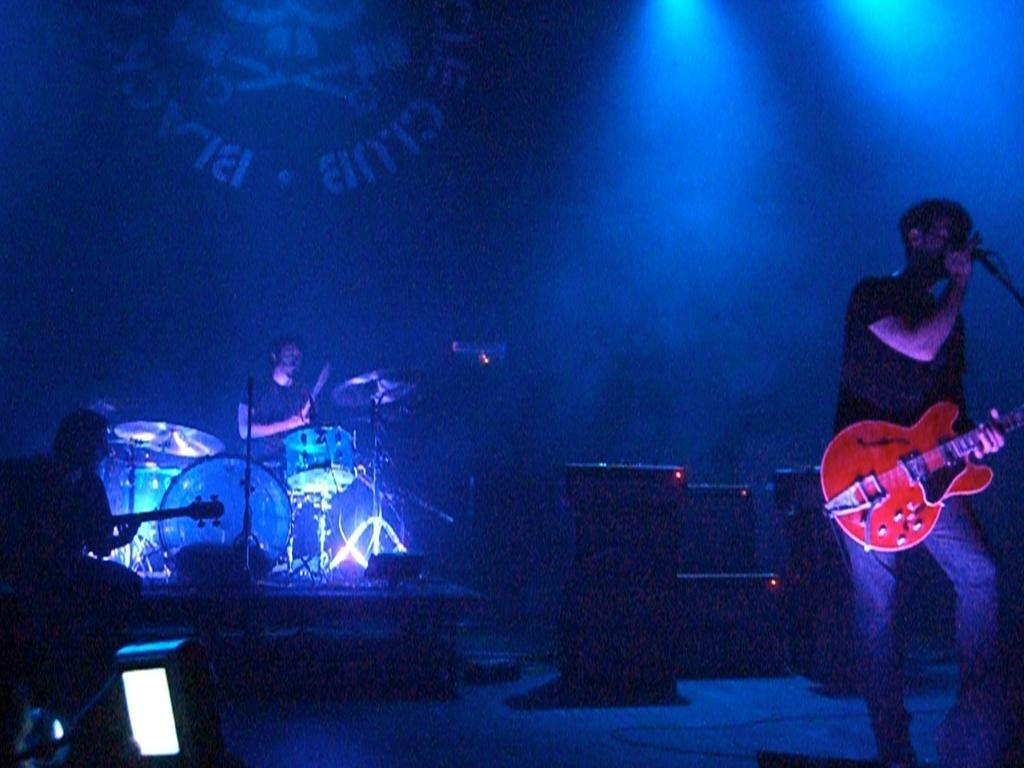Please provide a concise description of this image. In this picture we can see three persons playing musical instruments such as guitar, drums and singing on mic and in background we can see speakers, wall, light. 